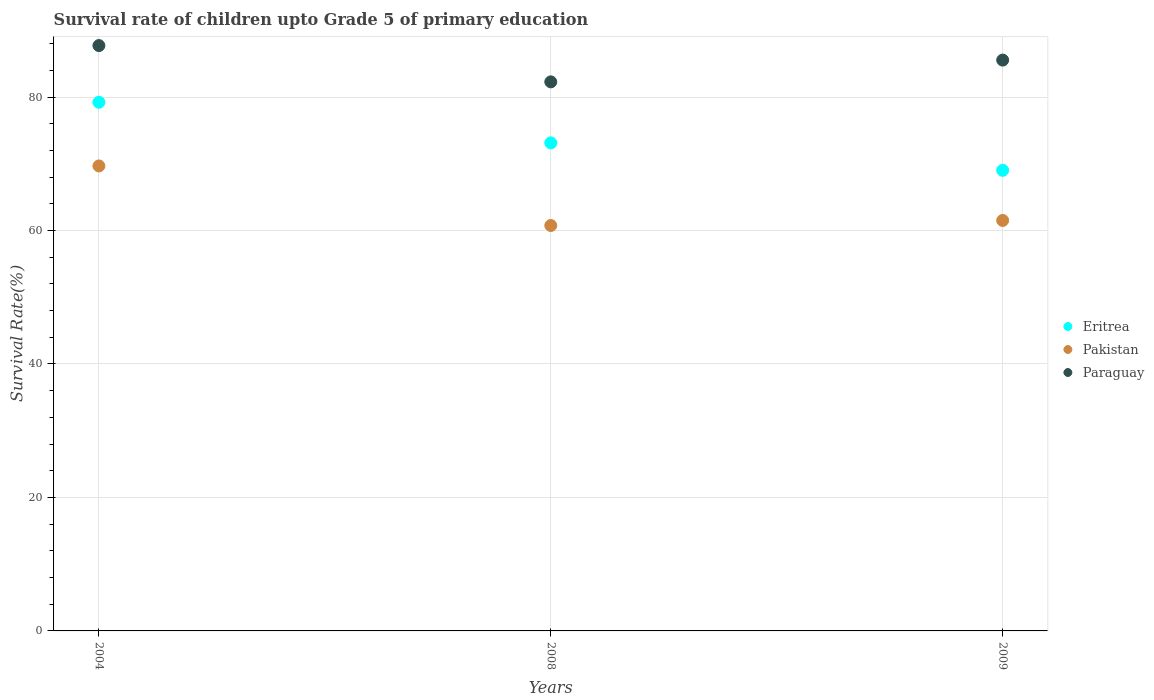How many different coloured dotlines are there?
Offer a terse response. 3. Is the number of dotlines equal to the number of legend labels?
Provide a short and direct response. Yes. What is the survival rate of children in Paraguay in 2004?
Your answer should be very brief. 87.71. Across all years, what is the maximum survival rate of children in Paraguay?
Your response must be concise. 87.71. Across all years, what is the minimum survival rate of children in Eritrea?
Your answer should be very brief. 69.02. In which year was the survival rate of children in Paraguay minimum?
Provide a short and direct response. 2008. What is the total survival rate of children in Pakistan in the graph?
Offer a terse response. 191.93. What is the difference between the survival rate of children in Eritrea in 2004 and that in 2009?
Keep it short and to the point. 10.2. What is the difference between the survival rate of children in Paraguay in 2004 and the survival rate of children in Eritrea in 2009?
Keep it short and to the point. 18.69. What is the average survival rate of children in Pakistan per year?
Provide a short and direct response. 63.98. In the year 2004, what is the difference between the survival rate of children in Pakistan and survival rate of children in Paraguay?
Provide a short and direct response. -18.04. In how many years, is the survival rate of children in Eritrea greater than 44 %?
Provide a succinct answer. 3. What is the ratio of the survival rate of children in Eritrea in 2004 to that in 2008?
Make the answer very short. 1.08. Is the survival rate of children in Eritrea in 2004 less than that in 2009?
Your answer should be compact. No. Is the difference between the survival rate of children in Pakistan in 2008 and 2009 greater than the difference between the survival rate of children in Paraguay in 2008 and 2009?
Make the answer very short. Yes. What is the difference between the highest and the second highest survival rate of children in Eritrea?
Offer a very short reply. 6.09. What is the difference between the highest and the lowest survival rate of children in Paraguay?
Keep it short and to the point. 5.44. Is the sum of the survival rate of children in Eritrea in 2004 and 2009 greater than the maximum survival rate of children in Paraguay across all years?
Your answer should be very brief. Yes. Is it the case that in every year, the sum of the survival rate of children in Pakistan and survival rate of children in Paraguay  is greater than the survival rate of children in Eritrea?
Your answer should be very brief. Yes. Does the survival rate of children in Pakistan monotonically increase over the years?
Provide a succinct answer. No. Is the survival rate of children in Eritrea strictly greater than the survival rate of children in Pakistan over the years?
Your answer should be very brief. Yes. Does the graph contain any zero values?
Ensure brevity in your answer.  No. How are the legend labels stacked?
Your answer should be very brief. Vertical. What is the title of the graph?
Provide a short and direct response. Survival rate of children upto Grade 5 of primary education. Does "High income: nonOECD" appear as one of the legend labels in the graph?
Provide a succinct answer. No. What is the label or title of the Y-axis?
Provide a short and direct response. Survival Rate(%). What is the Survival Rate(%) of Eritrea in 2004?
Keep it short and to the point. 79.22. What is the Survival Rate(%) in Pakistan in 2004?
Provide a short and direct response. 69.68. What is the Survival Rate(%) in Paraguay in 2004?
Give a very brief answer. 87.71. What is the Survival Rate(%) in Eritrea in 2008?
Keep it short and to the point. 73.13. What is the Survival Rate(%) in Pakistan in 2008?
Offer a terse response. 60.75. What is the Survival Rate(%) of Paraguay in 2008?
Provide a short and direct response. 82.27. What is the Survival Rate(%) of Eritrea in 2009?
Make the answer very short. 69.02. What is the Survival Rate(%) in Pakistan in 2009?
Keep it short and to the point. 61.51. What is the Survival Rate(%) of Paraguay in 2009?
Provide a short and direct response. 85.54. Across all years, what is the maximum Survival Rate(%) in Eritrea?
Provide a succinct answer. 79.22. Across all years, what is the maximum Survival Rate(%) in Pakistan?
Provide a short and direct response. 69.68. Across all years, what is the maximum Survival Rate(%) in Paraguay?
Make the answer very short. 87.71. Across all years, what is the minimum Survival Rate(%) in Eritrea?
Keep it short and to the point. 69.02. Across all years, what is the minimum Survival Rate(%) of Pakistan?
Offer a terse response. 60.75. Across all years, what is the minimum Survival Rate(%) of Paraguay?
Offer a terse response. 82.27. What is the total Survival Rate(%) in Eritrea in the graph?
Your answer should be compact. 221.37. What is the total Survival Rate(%) of Pakistan in the graph?
Your answer should be very brief. 191.93. What is the total Survival Rate(%) of Paraguay in the graph?
Give a very brief answer. 255.53. What is the difference between the Survival Rate(%) in Eritrea in 2004 and that in 2008?
Keep it short and to the point. 6.09. What is the difference between the Survival Rate(%) of Pakistan in 2004 and that in 2008?
Give a very brief answer. 8.93. What is the difference between the Survival Rate(%) of Paraguay in 2004 and that in 2008?
Provide a short and direct response. 5.44. What is the difference between the Survival Rate(%) of Eritrea in 2004 and that in 2009?
Offer a terse response. 10.2. What is the difference between the Survival Rate(%) of Pakistan in 2004 and that in 2009?
Offer a terse response. 8.17. What is the difference between the Survival Rate(%) in Paraguay in 2004 and that in 2009?
Give a very brief answer. 2.17. What is the difference between the Survival Rate(%) in Eritrea in 2008 and that in 2009?
Your answer should be compact. 4.11. What is the difference between the Survival Rate(%) in Pakistan in 2008 and that in 2009?
Ensure brevity in your answer.  -0.76. What is the difference between the Survival Rate(%) in Paraguay in 2008 and that in 2009?
Offer a terse response. -3.26. What is the difference between the Survival Rate(%) of Eritrea in 2004 and the Survival Rate(%) of Pakistan in 2008?
Your answer should be compact. 18.47. What is the difference between the Survival Rate(%) in Eritrea in 2004 and the Survival Rate(%) in Paraguay in 2008?
Give a very brief answer. -3.06. What is the difference between the Survival Rate(%) in Pakistan in 2004 and the Survival Rate(%) in Paraguay in 2008?
Offer a terse response. -12.6. What is the difference between the Survival Rate(%) in Eritrea in 2004 and the Survival Rate(%) in Pakistan in 2009?
Ensure brevity in your answer.  17.71. What is the difference between the Survival Rate(%) of Eritrea in 2004 and the Survival Rate(%) of Paraguay in 2009?
Provide a short and direct response. -6.32. What is the difference between the Survival Rate(%) in Pakistan in 2004 and the Survival Rate(%) in Paraguay in 2009?
Make the answer very short. -15.86. What is the difference between the Survival Rate(%) of Eritrea in 2008 and the Survival Rate(%) of Pakistan in 2009?
Keep it short and to the point. 11.63. What is the difference between the Survival Rate(%) of Eritrea in 2008 and the Survival Rate(%) of Paraguay in 2009?
Provide a succinct answer. -12.41. What is the difference between the Survival Rate(%) of Pakistan in 2008 and the Survival Rate(%) of Paraguay in 2009?
Offer a very short reply. -24.79. What is the average Survival Rate(%) in Eritrea per year?
Provide a short and direct response. 73.79. What is the average Survival Rate(%) in Pakistan per year?
Offer a very short reply. 63.98. What is the average Survival Rate(%) in Paraguay per year?
Ensure brevity in your answer.  85.18. In the year 2004, what is the difference between the Survival Rate(%) of Eritrea and Survival Rate(%) of Pakistan?
Your response must be concise. 9.54. In the year 2004, what is the difference between the Survival Rate(%) in Eritrea and Survival Rate(%) in Paraguay?
Keep it short and to the point. -8.49. In the year 2004, what is the difference between the Survival Rate(%) in Pakistan and Survival Rate(%) in Paraguay?
Offer a terse response. -18.04. In the year 2008, what is the difference between the Survival Rate(%) of Eritrea and Survival Rate(%) of Pakistan?
Offer a very short reply. 12.38. In the year 2008, what is the difference between the Survival Rate(%) in Eritrea and Survival Rate(%) in Paraguay?
Offer a terse response. -9.14. In the year 2008, what is the difference between the Survival Rate(%) in Pakistan and Survival Rate(%) in Paraguay?
Provide a succinct answer. -21.52. In the year 2009, what is the difference between the Survival Rate(%) of Eritrea and Survival Rate(%) of Pakistan?
Offer a very short reply. 7.51. In the year 2009, what is the difference between the Survival Rate(%) of Eritrea and Survival Rate(%) of Paraguay?
Make the answer very short. -16.52. In the year 2009, what is the difference between the Survival Rate(%) in Pakistan and Survival Rate(%) in Paraguay?
Your answer should be compact. -24.03. What is the ratio of the Survival Rate(%) of Eritrea in 2004 to that in 2008?
Keep it short and to the point. 1.08. What is the ratio of the Survival Rate(%) of Pakistan in 2004 to that in 2008?
Your response must be concise. 1.15. What is the ratio of the Survival Rate(%) in Paraguay in 2004 to that in 2008?
Offer a very short reply. 1.07. What is the ratio of the Survival Rate(%) in Eritrea in 2004 to that in 2009?
Keep it short and to the point. 1.15. What is the ratio of the Survival Rate(%) of Pakistan in 2004 to that in 2009?
Make the answer very short. 1.13. What is the ratio of the Survival Rate(%) in Paraguay in 2004 to that in 2009?
Your response must be concise. 1.03. What is the ratio of the Survival Rate(%) in Eritrea in 2008 to that in 2009?
Provide a succinct answer. 1.06. What is the ratio of the Survival Rate(%) of Paraguay in 2008 to that in 2009?
Provide a succinct answer. 0.96. What is the difference between the highest and the second highest Survival Rate(%) in Eritrea?
Keep it short and to the point. 6.09. What is the difference between the highest and the second highest Survival Rate(%) of Pakistan?
Provide a short and direct response. 8.17. What is the difference between the highest and the second highest Survival Rate(%) in Paraguay?
Provide a short and direct response. 2.17. What is the difference between the highest and the lowest Survival Rate(%) of Eritrea?
Offer a very short reply. 10.2. What is the difference between the highest and the lowest Survival Rate(%) of Pakistan?
Give a very brief answer. 8.93. What is the difference between the highest and the lowest Survival Rate(%) of Paraguay?
Provide a short and direct response. 5.44. 